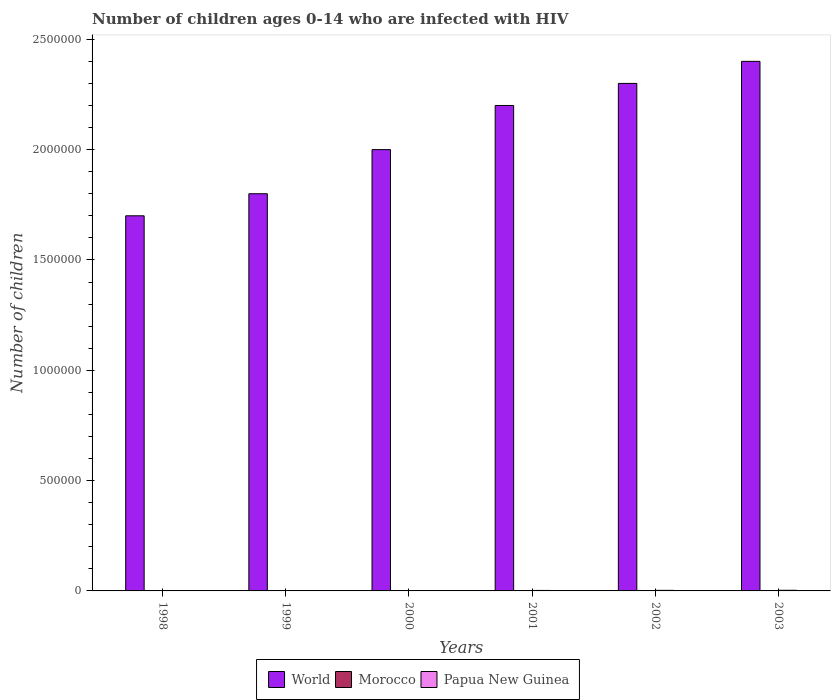How many different coloured bars are there?
Make the answer very short. 3. Are the number of bars per tick equal to the number of legend labels?
Keep it short and to the point. Yes. How many bars are there on the 3rd tick from the left?
Your answer should be very brief. 3. In how many cases, is the number of bars for a given year not equal to the number of legend labels?
Your answer should be compact. 0. What is the number of HIV infected children in World in 2001?
Your answer should be compact. 2.20e+06. Across all years, what is the maximum number of HIV infected children in World?
Your answer should be compact. 2.40e+06. Across all years, what is the minimum number of HIV infected children in Papua New Guinea?
Your answer should be very brief. 1200. In which year was the number of HIV infected children in World maximum?
Give a very brief answer. 2003. What is the total number of HIV infected children in Papua New Guinea in the graph?
Offer a very short reply. 1.23e+04. What is the difference between the number of HIV infected children in Papua New Guinea in 1999 and that in 2002?
Your response must be concise. -1100. What is the difference between the number of HIV infected children in Morocco in 2001 and the number of HIV infected children in Papua New Guinea in 1999?
Make the answer very short. -1000. What is the average number of HIV infected children in World per year?
Ensure brevity in your answer.  2.07e+06. In the year 1998, what is the difference between the number of HIV infected children in Morocco and number of HIV infected children in Papua New Guinea?
Offer a very short reply. -1000. In how many years, is the number of HIV infected children in World greater than 600000?
Offer a very short reply. 6. What is the ratio of the number of HIV infected children in Papua New Guinea in 2000 to that in 2002?
Your answer should be very brief. 0.73. Is the number of HIV infected children in World in 1998 less than that in 2003?
Keep it short and to the point. Yes. Is the difference between the number of HIV infected children in Morocco in 1998 and 2000 greater than the difference between the number of HIV infected children in Papua New Guinea in 1998 and 2000?
Offer a terse response. Yes. What is the difference between the highest and the second highest number of HIV infected children in Papua New Guinea?
Make the answer very short. 300. What is the difference between the highest and the lowest number of HIV infected children in World?
Your response must be concise. 7.00e+05. What does the 3rd bar from the left in 1998 represents?
Provide a short and direct response. Papua New Guinea. What does the 3rd bar from the right in 2002 represents?
Your response must be concise. World. Is it the case that in every year, the sum of the number of HIV infected children in Papua New Guinea and number of HIV infected children in World is greater than the number of HIV infected children in Morocco?
Offer a very short reply. Yes. Are all the bars in the graph horizontal?
Your response must be concise. No. What is the difference between two consecutive major ticks on the Y-axis?
Keep it short and to the point. 5.00e+05. How many legend labels are there?
Your answer should be very brief. 3. How are the legend labels stacked?
Offer a very short reply. Horizontal. What is the title of the graph?
Your answer should be compact. Number of children ages 0-14 who are infected with HIV. What is the label or title of the X-axis?
Give a very brief answer. Years. What is the label or title of the Y-axis?
Keep it short and to the point. Number of children. What is the Number of children of World in 1998?
Make the answer very short. 1.70e+06. What is the Number of children of Papua New Guinea in 1998?
Provide a short and direct response. 1200. What is the Number of children of World in 1999?
Provide a succinct answer. 1.80e+06. What is the Number of children of Morocco in 1999?
Make the answer very short. 200. What is the Number of children of Papua New Guinea in 1999?
Your answer should be very brief. 1500. What is the Number of children of World in 2000?
Your response must be concise. 2.00e+06. What is the Number of children of Morocco in 2000?
Ensure brevity in your answer.  500. What is the Number of children in Papua New Guinea in 2000?
Give a very brief answer. 1900. What is the Number of children of World in 2001?
Give a very brief answer. 2.20e+06. What is the Number of children of Morocco in 2001?
Offer a terse response. 500. What is the Number of children of Papua New Guinea in 2001?
Your response must be concise. 2200. What is the Number of children in World in 2002?
Keep it short and to the point. 2.30e+06. What is the Number of children of Morocco in 2002?
Offer a terse response. 500. What is the Number of children of Papua New Guinea in 2002?
Your answer should be very brief. 2600. What is the Number of children of World in 2003?
Your answer should be compact. 2.40e+06. What is the Number of children in Morocco in 2003?
Provide a short and direct response. 500. What is the Number of children in Papua New Guinea in 2003?
Your response must be concise. 2900. Across all years, what is the maximum Number of children of World?
Your answer should be very brief. 2.40e+06. Across all years, what is the maximum Number of children of Morocco?
Give a very brief answer. 500. Across all years, what is the maximum Number of children in Papua New Guinea?
Your answer should be very brief. 2900. Across all years, what is the minimum Number of children in World?
Offer a terse response. 1.70e+06. Across all years, what is the minimum Number of children of Morocco?
Make the answer very short. 200. Across all years, what is the minimum Number of children of Papua New Guinea?
Your response must be concise. 1200. What is the total Number of children of World in the graph?
Your answer should be compact. 1.24e+07. What is the total Number of children in Morocco in the graph?
Give a very brief answer. 2400. What is the total Number of children in Papua New Guinea in the graph?
Your answer should be very brief. 1.23e+04. What is the difference between the Number of children of World in 1998 and that in 1999?
Offer a very short reply. -1.00e+05. What is the difference between the Number of children in Papua New Guinea in 1998 and that in 1999?
Your response must be concise. -300. What is the difference between the Number of children of World in 1998 and that in 2000?
Your response must be concise. -3.00e+05. What is the difference between the Number of children in Morocco in 1998 and that in 2000?
Offer a terse response. -300. What is the difference between the Number of children of Papua New Guinea in 1998 and that in 2000?
Offer a terse response. -700. What is the difference between the Number of children of World in 1998 and that in 2001?
Provide a short and direct response. -5.00e+05. What is the difference between the Number of children of Morocco in 1998 and that in 2001?
Make the answer very short. -300. What is the difference between the Number of children in Papua New Guinea in 1998 and that in 2001?
Offer a very short reply. -1000. What is the difference between the Number of children in World in 1998 and that in 2002?
Offer a terse response. -6.00e+05. What is the difference between the Number of children of Morocco in 1998 and that in 2002?
Provide a short and direct response. -300. What is the difference between the Number of children of Papua New Guinea in 1998 and that in 2002?
Keep it short and to the point. -1400. What is the difference between the Number of children of World in 1998 and that in 2003?
Make the answer very short. -7.00e+05. What is the difference between the Number of children in Morocco in 1998 and that in 2003?
Give a very brief answer. -300. What is the difference between the Number of children in Papua New Guinea in 1998 and that in 2003?
Provide a succinct answer. -1700. What is the difference between the Number of children of World in 1999 and that in 2000?
Offer a terse response. -2.00e+05. What is the difference between the Number of children of Morocco in 1999 and that in 2000?
Keep it short and to the point. -300. What is the difference between the Number of children of Papua New Guinea in 1999 and that in 2000?
Provide a short and direct response. -400. What is the difference between the Number of children of World in 1999 and that in 2001?
Offer a very short reply. -4.00e+05. What is the difference between the Number of children in Morocco in 1999 and that in 2001?
Keep it short and to the point. -300. What is the difference between the Number of children in Papua New Guinea in 1999 and that in 2001?
Give a very brief answer. -700. What is the difference between the Number of children of World in 1999 and that in 2002?
Offer a terse response. -5.00e+05. What is the difference between the Number of children in Morocco in 1999 and that in 2002?
Make the answer very short. -300. What is the difference between the Number of children in Papua New Guinea in 1999 and that in 2002?
Make the answer very short. -1100. What is the difference between the Number of children in World in 1999 and that in 2003?
Keep it short and to the point. -6.00e+05. What is the difference between the Number of children in Morocco in 1999 and that in 2003?
Your answer should be very brief. -300. What is the difference between the Number of children in Papua New Guinea in 1999 and that in 2003?
Your answer should be compact. -1400. What is the difference between the Number of children of Morocco in 2000 and that in 2001?
Offer a terse response. 0. What is the difference between the Number of children of Papua New Guinea in 2000 and that in 2001?
Give a very brief answer. -300. What is the difference between the Number of children of World in 2000 and that in 2002?
Give a very brief answer. -3.00e+05. What is the difference between the Number of children in Papua New Guinea in 2000 and that in 2002?
Your answer should be very brief. -700. What is the difference between the Number of children of World in 2000 and that in 2003?
Offer a very short reply. -4.00e+05. What is the difference between the Number of children of Papua New Guinea in 2000 and that in 2003?
Offer a terse response. -1000. What is the difference between the Number of children of Papua New Guinea in 2001 and that in 2002?
Provide a succinct answer. -400. What is the difference between the Number of children in World in 2001 and that in 2003?
Offer a terse response. -2.00e+05. What is the difference between the Number of children in Morocco in 2001 and that in 2003?
Make the answer very short. 0. What is the difference between the Number of children of Papua New Guinea in 2001 and that in 2003?
Offer a terse response. -700. What is the difference between the Number of children of World in 2002 and that in 2003?
Provide a short and direct response. -1.00e+05. What is the difference between the Number of children of Papua New Guinea in 2002 and that in 2003?
Provide a succinct answer. -300. What is the difference between the Number of children in World in 1998 and the Number of children in Morocco in 1999?
Ensure brevity in your answer.  1.70e+06. What is the difference between the Number of children in World in 1998 and the Number of children in Papua New Guinea in 1999?
Offer a terse response. 1.70e+06. What is the difference between the Number of children of Morocco in 1998 and the Number of children of Papua New Guinea in 1999?
Offer a very short reply. -1300. What is the difference between the Number of children of World in 1998 and the Number of children of Morocco in 2000?
Your response must be concise. 1.70e+06. What is the difference between the Number of children of World in 1998 and the Number of children of Papua New Guinea in 2000?
Provide a succinct answer. 1.70e+06. What is the difference between the Number of children in Morocco in 1998 and the Number of children in Papua New Guinea in 2000?
Your response must be concise. -1700. What is the difference between the Number of children of World in 1998 and the Number of children of Morocco in 2001?
Keep it short and to the point. 1.70e+06. What is the difference between the Number of children in World in 1998 and the Number of children in Papua New Guinea in 2001?
Your response must be concise. 1.70e+06. What is the difference between the Number of children in Morocco in 1998 and the Number of children in Papua New Guinea in 2001?
Your answer should be very brief. -2000. What is the difference between the Number of children in World in 1998 and the Number of children in Morocco in 2002?
Offer a terse response. 1.70e+06. What is the difference between the Number of children in World in 1998 and the Number of children in Papua New Guinea in 2002?
Provide a succinct answer. 1.70e+06. What is the difference between the Number of children in Morocco in 1998 and the Number of children in Papua New Guinea in 2002?
Ensure brevity in your answer.  -2400. What is the difference between the Number of children of World in 1998 and the Number of children of Morocco in 2003?
Your answer should be very brief. 1.70e+06. What is the difference between the Number of children in World in 1998 and the Number of children in Papua New Guinea in 2003?
Make the answer very short. 1.70e+06. What is the difference between the Number of children in Morocco in 1998 and the Number of children in Papua New Guinea in 2003?
Offer a terse response. -2700. What is the difference between the Number of children in World in 1999 and the Number of children in Morocco in 2000?
Offer a terse response. 1.80e+06. What is the difference between the Number of children in World in 1999 and the Number of children in Papua New Guinea in 2000?
Provide a short and direct response. 1.80e+06. What is the difference between the Number of children of Morocco in 1999 and the Number of children of Papua New Guinea in 2000?
Offer a terse response. -1700. What is the difference between the Number of children in World in 1999 and the Number of children in Morocco in 2001?
Your response must be concise. 1.80e+06. What is the difference between the Number of children in World in 1999 and the Number of children in Papua New Guinea in 2001?
Provide a short and direct response. 1.80e+06. What is the difference between the Number of children in Morocco in 1999 and the Number of children in Papua New Guinea in 2001?
Your answer should be very brief. -2000. What is the difference between the Number of children of World in 1999 and the Number of children of Morocco in 2002?
Provide a short and direct response. 1.80e+06. What is the difference between the Number of children of World in 1999 and the Number of children of Papua New Guinea in 2002?
Offer a very short reply. 1.80e+06. What is the difference between the Number of children of Morocco in 1999 and the Number of children of Papua New Guinea in 2002?
Offer a very short reply. -2400. What is the difference between the Number of children in World in 1999 and the Number of children in Morocco in 2003?
Ensure brevity in your answer.  1.80e+06. What is the difference between the Number of children of World in 1999 and the Number of children of Papua New Guinea in 2003?
Offer a very short reply. 1.80e+06. What is the difference between the Number of children of Morocco in 1999 and the Number of children of Papua New Guinea in 2003?
Offer a very short reply. -2700. What is the difference between the Number of children in World in 2000 and the Number of children in Morocco in 2001?
Provide a short and direct response. 2.00e+06. What is the difference between the Number of children of World in 2000 and the Number of children of Papua New Guinea in 2001?
Your answer should be compact. 2.00e+06. What is the difference between the Number of children in Morocco in 2000 and the Number of children in Papua New Guinea in 2001?
Provide a short and direct response. -1700. What is the difference between the Number of children in World in 2000 and the Number of children in Morocco in 2002?
Offer a terse response. 2.00e+06. What is the difference between the Number of children in World in 2000 and the Number of children in Papua New Guinea in 2002?
Offer a very short reply. 2.00e+06. What is the difference between the Number of children in Morocco in 2000 and the Number of children in Papua New Guinea in 2002?
Provide a succinct answer. -2100. What is the difference between the Number of children in World in 2000 and the Number of children in Morocco in 2003?
Provide a succinct answer. 2.00e+06. What is the difference between the Number of children in World in 2000 and the Number of children in Papua New Guinea in 2003?
Your response must be concise. 2.00e+06. What is the difference between the Number of children in Morocco in 2000 and the Number of children in Papua New Guinea in 2003?
Provide a succinct answer. -2400. What is the difference between the Number of children of World in 2001 and the Number of children of Morocco in 2002?
Make the answer very short. 2.20e+06. What is the difference between the Number of children of World in 2001 and the Number of children of Papua New Guinea in 2002?
Give a very brief answer. 2.20e+06. What is the difference between the Number of children of Morocco in 2001 and the Number of children of Papua New Guinea in 2002?
Your answer should be compact. -2100. What is the difference between the Number of children in World in 2001 and the Number of children in Morocco in 2003?
Offer a terse response. 2.20e+06. What is the difference between the Number of children in World in 2001 and the Number of children in Papua New Guinea in 2003?
Make the answer very short. 2.20e+06. What is the difference between the Number of children of Morocco in 2001 and the Number of children of Papua New Guinea in 2003?
Ensure brevity in your answer.  -2400. What is the difference between the Number of children of World in 2002 and the Number of children of Morocco in 2003?
Your answer should be compact. 2.30e+06. What is the difference between the Number of children in World in 2002 and the Number of children in Papua New Guinea in 2003?
Ensure brevity in your answer.  2.30e+06. What is the difference between the Number of children of Morocco in 2002 and the Number of children of Papua New Guinea in 2003?
Give a very brief answer. -2400. What is the average Number of children of World per year?
Keep it short and to the point. 2.07e+06. What is the average Number of children in Papua New Guinea per year?
Offer a terse response. 2050. In the year 1998, what is the difference between the Number of children in World and Number of children in Morocco?
Provide a short and direct response. 1.70e+06. In the year 1998, what is the difference between the Number of children of World and Number of children of Papua New Guinea?
Provide a succinct answer. 1.70e+06. In the year 1998, what is the difference between the Number of children in Morocco and Number of children in Papua New Guinea?
Make the answer very short. -1000. In the year 1999, what is the difference between the Number of children in World and Number of children in Morocco?
Offer a very short reply. 1.80e+06. In the year 1999, what is the difference between the Number of children in World and Number of children in Papua New Guinea?
Offer a terse response. 1.80e+06. In the year 1999, what is the difference between the Number of children in Morocco and Number of children in Papua New Guinea?
Your answer should be compact. -1300. In the year 2000, what is the difference between the Number of children of World and Number of children of Morocco?
Your answer should be compact. 2.00e+06. In the year 2000, what is the difference between the Number of children of World and Number of children of Papua New Guinea?
Your answer should be compact. 2.00e+06. In the year 2000, what is the difference between the Number of children of Morocco and Number of children of Papua New Guinea?
Give a very brief answer. -1400. In the year 2001, what is the difference between the Number of children of World and Number of children of Morocco?
Your answer should be very brief. 2.20e+06. In the year 2001, what is the difference between the Number of children in World and Number of children in Papua New Guinea?
Your answer should be very brief. 2.20e+06. In the year 2001, what is the difference between the Number of children of Morocco and Number of children of Papua New Guinea?
Your answer should be compact. -1700. In the year 2002, what is the difference between the Number of children in World and Number of children in Morocco?
Your answer should be compact. 2.30e+06. In the year 2002, what is the difference between the Number of children in World and Number of children in Papua New Guinea?
Offer a very short reply. 2.30e+06. In the year 2002, what is the difference between the Number of children in Morocco and Number of children in Papua New Guinea?
Make the answer very short. -2100. In the year 2003, what is the difference between the Number of children in World and Number of children in Morocco?
Your response must be concise. 2.40e+06. In the year 2003, what is the difference between the Number of children of World and Number of children of Papua New Guinea?
Offer a very short reply. 2.40e+06. In the year 2003, what is the difference between the Number of children in Morocco and Number of children in Papua New Guinea?
Your answer should be very brief. -2400. What is the ratio of the Number of children in Morocco in 1998 to that in 1999?
Your answer should be compact. 1. What is the ratio of the Number of children in Papua New Guinea in 1998 to that in 1999?
Provide a short and direct response. 0.8. What is the ratio of the Number of children of Papua New Guinea in 1998 to that in 2000?
Offer a terse response. 0.63. What is the ratio of the Number of children in World in 1998 to that in 2001?
Your answer should be very brief. 0.77. What is the ratio of the Number of children in Papua New Guinea in 1998 to that in 2001?
Ensure brevity in your answer.  0.55. What is the ratio of the Number of children in World in 1998 to that in 2002?
Offer a terse response. 0.74. What is the ratio of the Number of children of Papua New Guinea in 1998 to that in 2002?
Give a very brief answer. 0.46. What is the ratio of the Number of children in World in 1998 to that in 2003?
Ensure brevity in your answer.  0.71. What is the ratio of the Number of children of Papua New Guinea in 1998 to that in 2003?
Your answer should be compact. 0.41. What is the ratio of the Number of children of World in 1999 to that in 2000?
Make the answer very short. 0.9. What is the ratio of the Number of children in Morocco in 1999 to that in 2000?
Your response must be concise. 0.4. What is the ratio of the Number of children in Papua New Guinea in 1999 to that in 2000?
Offer a very short reply. 0.79. What is the ratio of the Number of children of World in 1999 to that in 2001?
Offer a terse response. 0.82. What is the ratio of the Number of children of Papua New Guinea in 1999 to that in 2001?
Ensure brevity in your answer.  0.68. What is the ratio of the Number of children of World in 1999 to that in 2002?
Offer a very short reply. 0.78. What is the ratio of the Number of children of Morocco in 1999 to that in 2002?
Make the answer very short. 0.4. What is the ratio of the Number of children in Papua New Guinea in 1999 to that in 2002?
Provide a short and direct response. 0.58. What is the ratio of the Number of children of Morocco in 1999 to that in 2003?
Offer a terse response. 0.4. What is the ratio of the Number of children in Papua New Guinea in 1999 to that in 2003?
Provide a succinct answer. 0.52. What is the ratio of the Number of children of Morocco in 2000 to that in 2001?
Ensure brevity in your answer.  1. What is the ratio of the Number of children of Papua New Guinea in 2000 to that in 2001?
Provide a short and direct response. 0.86. What is the ratio of the Number of children of World in 2000 to that in 2002?
Provide a succinct answer. 0.87. What is the ratio of the Number of children in Papua New Guinea in 2000 to that in 2002?
Make the answer very short. 0.73. What is the ratio of the Number of children of Morocco in 2000 to that in 2003?
Offer a very short reply. 1. What is the ratio of the Number of children of Papua New Guinea in 2000 to that in 2003?
Ensure brevity in your answer.  0.66. What is the ratio of the Number of children in World in 2001 to that in 2002?
Your answer should be very brief. 0.96. What is the ratio of the Number of children in Morocco in 2001 to that in 2002?
Ensure brevity in your answer.  1. What is the ratio of the Number of children of Papua New Guinea in 2001 to that in 2002?
Your answer should be compact. 0.85. What is the ratio of the Number of children in Papua New Guinea in 2001 to that in 2003?
Keep it short and to the point. 0.76. What is the ratio of the Number of children in World in 2002 to that in 2003?
Keep it short and to the point. 0.96. What is the ratio of the Number of children of Papua New Guinea in 2002 to that in 2003?
Offer a terse response. 0.9. What is the difference between the highest and the second highest Number of children in World?
Your answer should be compact. 1.00e+05. What is the difference between the highest and the second highest Number of children in Morocco?
Keep it short and to the point. 0. What is the difference between the highest and the second highest Number of children in Papua New Guinea?
Provide a succinct answer. 300. What is the difference between the highest and the lowest Number of children in Morocco?
Ensure brevity in your answer.  300. What is the difference between the highest and the lowest Number of children of Papua New Guinea?
Ensure brevity in your answer.  1700. 